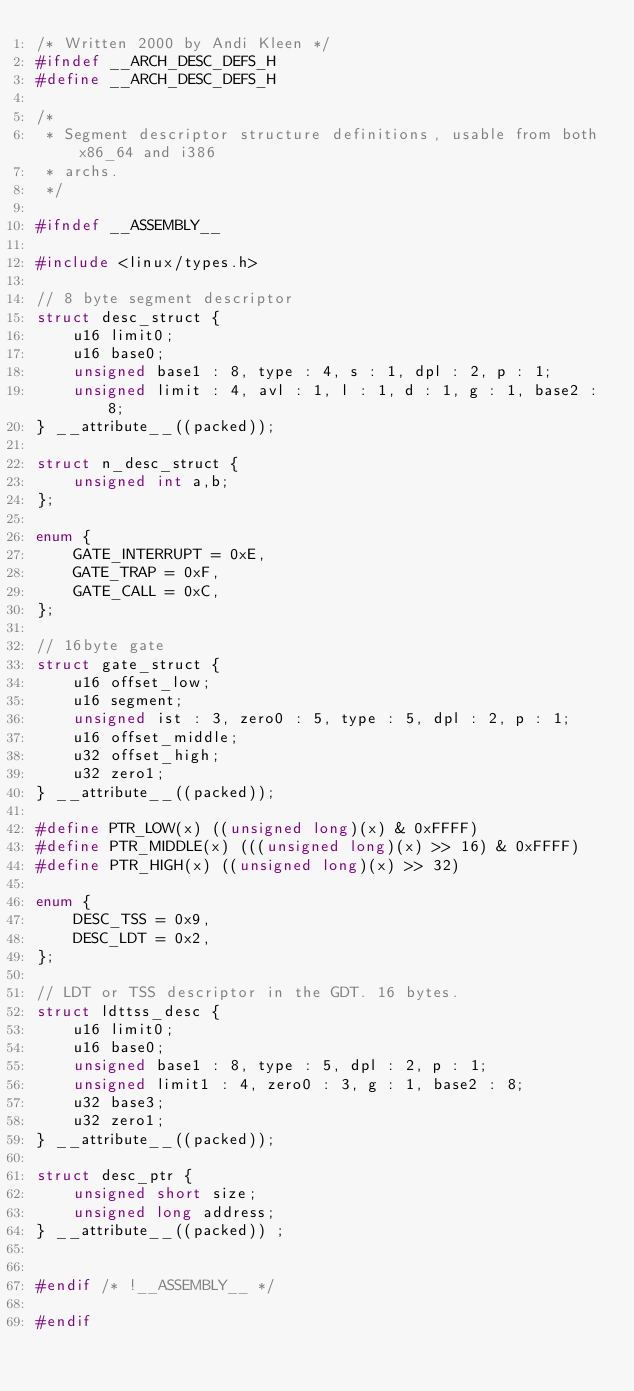<code> <loc_0><loc_0><loc_500><loc_500><_C_>/* Written 2000 by Andi Kleen */
#ifndef __ARCH_DESC_DEFS_H
#define __ARCH_DESC_DEFS_H

/*
 * Segment descriptor structure definitions, usable from both x86_64 and i386
 * archs.
 */

#ifndef __ASSEMBLY__

#include <linux/types.h>

// 8 byte segment descriptor
struct desc_struct {
	u16 limit0;
	u16 base0;
	unsigned base1 : 8, type : 4, s : 1, dpl : 2, p : 1;
	unsigned limit : 4, avl : 1, l : 1, d : 1, g : 1, base2 : 8;
} __attribute__((packed));

struct n_desc_struct {
	unsigned int a,b;
};

enum {
	GATE_INTERRUPT = 0xE,
	GATE_TRAP = 0xF,
	GATE_CALL = 0xC,
};

// 16byte gate
struct gate_struct {
	u16 offset_low;
	u16 segment;
	unsigned ist : 3, zero0 : 5, type : 5, dpl : 2, p : 1;
	u16 offset_middle;
	u32 offset_high;
	u32 zero1;
} __attribute__((packed));

#define PTR_LOW(x) ((unsigned long)(x) & 0xFFFF)
#define PTR_MIDDLE(x) (((unsigned long)(x) >> 16) & 0xFFFF)
#define PTR_HIGH(x) ((unsigned long)(x) >> 32)

enum {
	DESC_TSS = 0x9,
	DESC_LDT = 0x2,
};

// LDT or TSS descriptor in the GDT. 16 bytes.
struct ldttss_desc {
	u16 limit0;
	u16 base0;
	unsigned base1 : 8, type : 5, dpl : 2, p : 1;
	unsigned limit1 : 4, zero0 : 3, g : 1, base2 : 8;
	u32 base3;
	u32 zero1;
} __attribute__((packed));

struct desc_ptr {
	unsigned short size;
	unsigned long address;
} __attribute__((packed)) ;


#endif /* !__ASSEMBLY__ */

#endif
</code> 